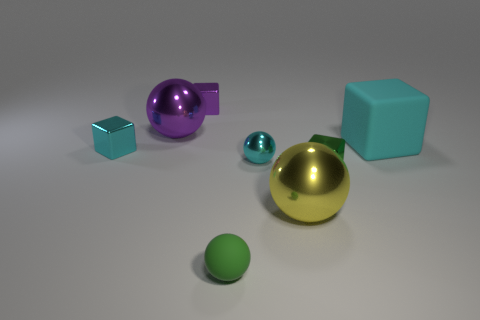Is there another cyan object of the same shape as the big cyan object?
Offer a very short reply. Yes. There is another matte sphere that is the same size as the cyan ball; what color is it?
Your answer should be compact. Green. What is the big ball in front of the big rubber thing made of?
Give a very brief answer. Metal. There is a small cyan object that is right of the tiny green rubber object; is its shape the same as the small object in front of the yellow thing?
Your answer should be very brief. Yes. Are there an equal number of purple things that are on the right side of the small green sphere and small purple shiny blocks?
Provide a short and direct response. No. How many green things have the same material as the purple ball?
Offer a terse response. 1. What is the color of the sphere that is made of the same material as the large cyan object?
Your response must be concise. Green. There is a cyan sphere; is it the same size as the matte thing that is behind the tiny metal ball?
Your answer should be compact. No. The big cyan object has what shape?
Keep it short and to the point. Cube. How many large metal objects have the same color as the big cube?
Keep it short and to the point. 0. 